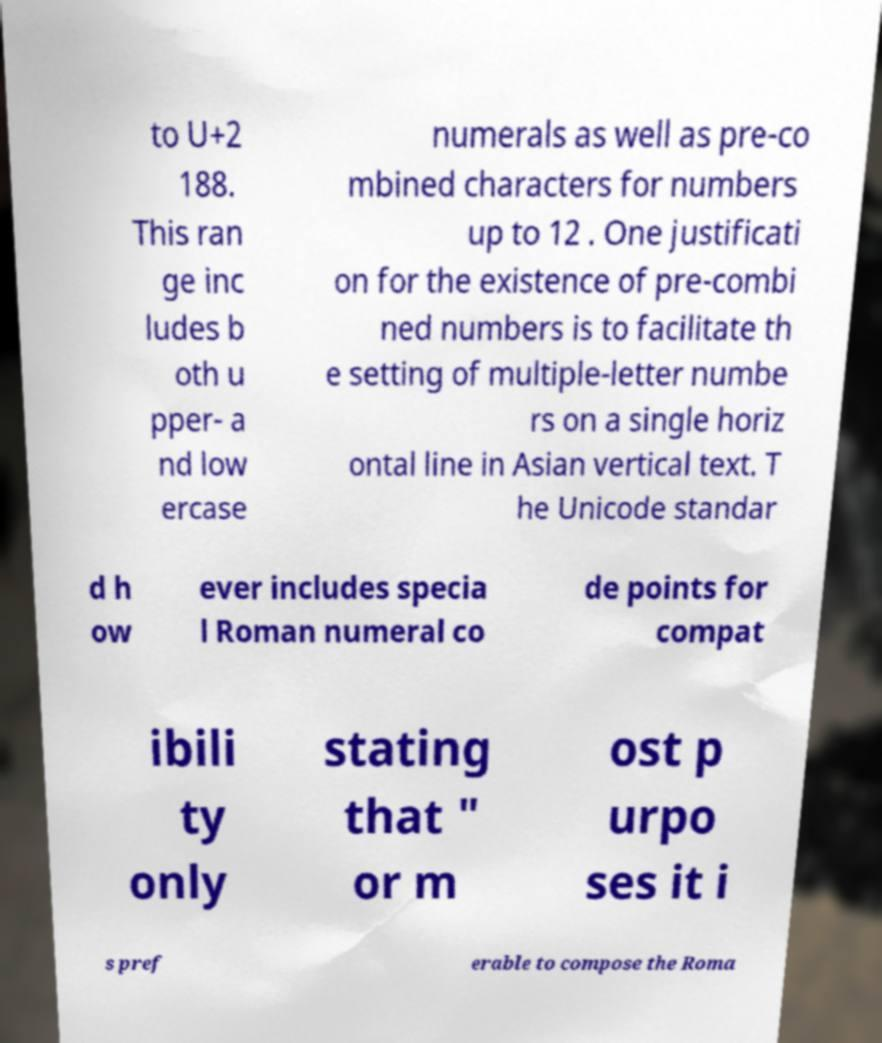Please read and relay the text visible in this image. What does it say? to U+2 188. This ran ge inc ludes b oth u pper- a nd low ercase numerals as well as pre-co mbined characters for numbers up to 12 . One justificati on for the existence of pre-combi ned numbers is to facilitate th e setting of multiple-letter numbe rs on a single horiz ontal line in Asian vertical text. T he Unicode standar d h ow ever includes specia l Roman numeral co de points for compat ibili ty only stating that " or m ost p urpo ses it i s pref erable to compose the Roma 